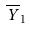Convert formula to latex. <formula><loc_0><loc_0><loc_500><loc_500>\overline { Y } _ { 1 }</formula> 